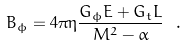<formula> <loc_0><loc_0><loc_500><loc_500>B _ { \phi } = 4 \pi \eta \frac { G _ { \phi } E + G _ { t } L } { M ^ { 2 } - \alpha } \ . \</formula> 